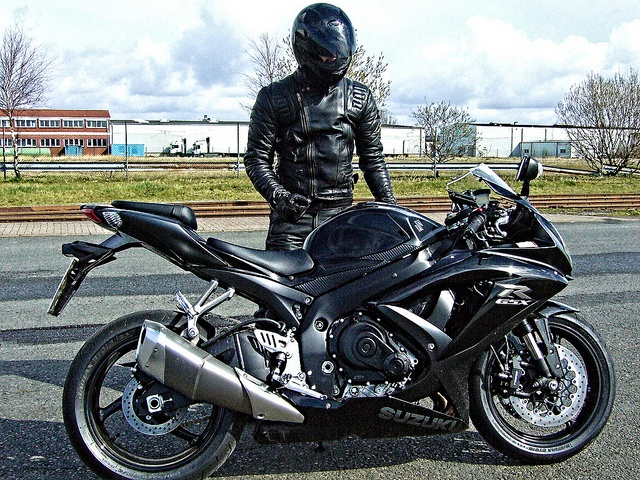Describe the objects in this image and their specific colors. I can see motorcycle in white, black, gray, and darkgray tones, people in white, black, gray, and darkgray tones, and truck in white, black, darkgray, and gray tones in this image. 